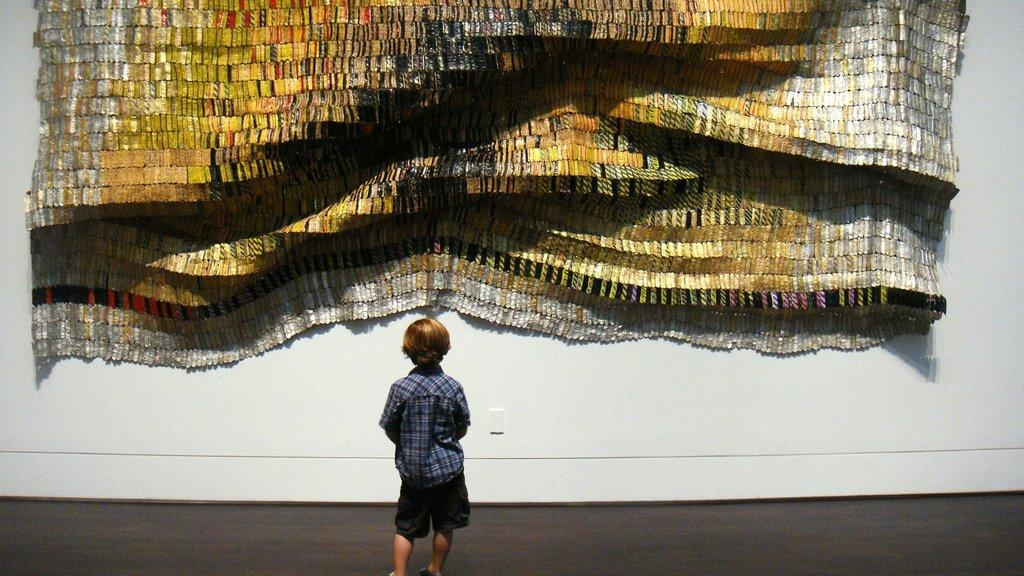What is the main subject of the image? There is a child in the image. What is the child wearing? The child is wearing a shirt. Where is the child standing? The child is standing on the floor. What can be seen on the wall in the image? There is a design on the wall. What colors are used in the design on the wall? The design on the wall is in gold and silver colors. How many rings can be seen on the child's fingers in the image? There are no rings visible on the child's fingers in the image. Is there a clubhouse in the background of the image? There is no clubhouse or any indication of a club in the image; it features a child, a shirt, a floor, and a design on the wall. 